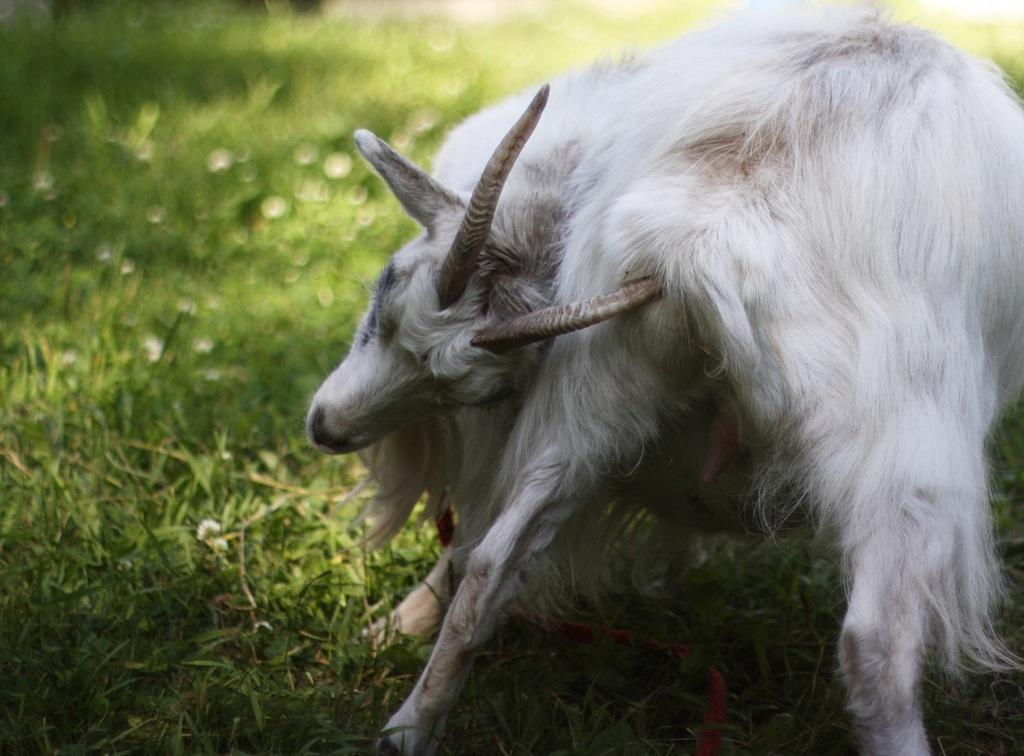What animal is present in the image? There is a goat in the image. What is the color of the goat? The goat is white in color. What type of vegetation can be seen at the bottom of the image? There is grass visible at the bottom of the image. What type of ornament is the goat wearing in the image? There is no ornament visible on the goat in the image. How does the woman in the image wash the goat? There is no woman present in the image, so it is not possible to answer this question. 